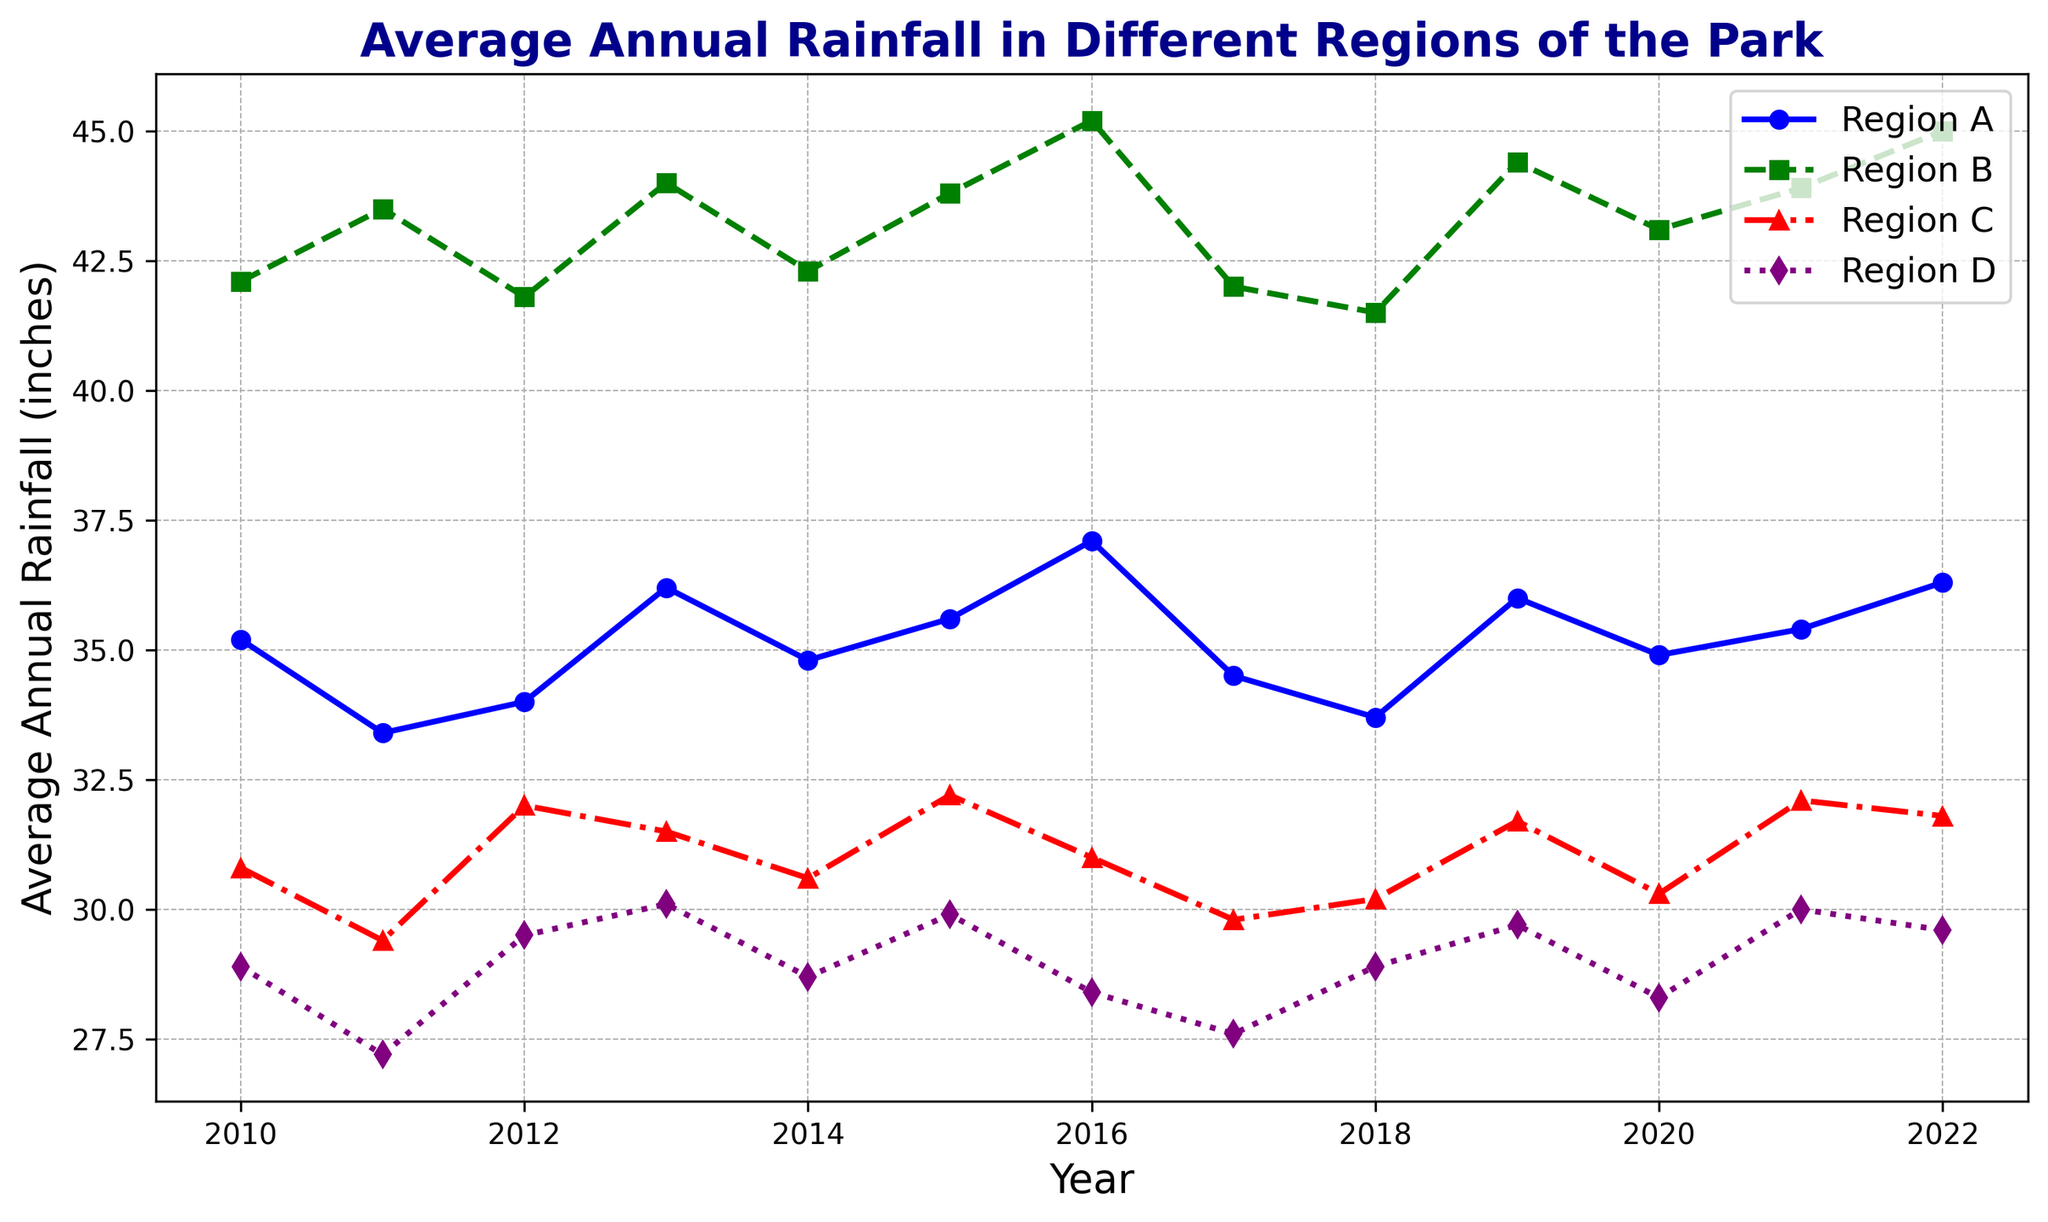What's the trend of the average annual rainfall in Region A from 2010 to 2022? To determine the trend in Region A, observe the plotted line representing Region A (blue line). The line generally rises over the years, suggesting an increasing trend in average annual rainfall.
Answer: Increasing trend Which year had the highest average annual rainfall in Region B, and what was the value? Identify the highest point on the green dashed line that represents Region B and check the corresponding year. In 2016, Region B had the highest rainfall at 45.2 inches.
Answer: 2016, 45.2 inches Between 2015 and 2019, did Region C see an increase or decrease in average annual rainfall? Look at the red dashed-dotted line for Region C and compare its values from 2015 to 2019. In 2015, the value is 32.2 inches, and in 2019, it is 31.7 inches, indicating a slight decrease.
Answer: Decrease Which region had the most fluctuating annual rainfall from 2010 to 2022? By observing all lines on the chart, Region B (green dashed line) shows the most significant variations in its values, indicating the highest fluctuation.
Answer: Region B On average, which region had the least average annual rainfall over the selected years? To find the average, calculate the mean rainfall for each region over the years. Summing the values and dividing by the number of years for Region D (purple dotted line) gives the smallest average value compared to other regions.
Answer: Region D In 2020, how did the average annual rainfall of Region D compare to Region A? Compare the value of Region D (purple dotted line) and Region A (blue line) in 2020. Region D's rainfall is 28.3 inches while Region A's rainfall is 34.9 inches.
Answer: Region A had higher rainfall What's the average rainfall in Region C in years when it was lower than 31 inches? Find the years where Region C (red dashed-dotted line) had values lower than 31 inches, which occurs in 2010, 2011, 2017, and 2020. The rainfall values for these years are 30.8, 29.4, 29.8, and 30.3 inches. Compute their average: (30.8 + 29.4 + 29.8 + 30.3) / 4 = 30.08 inches.
Answer: 30.08 inches Which year saw the smallest difference in average annual rainfall between Region A and Region D? To find the smallest difference, subtract the annual rainfall of Region D from Region A for each year and compare the results. The smallest difference is in 2010, with Region A at 35.2 inches and Region D at 28.9 inches. The difference is 35.2 - 28.9 = 6.3 inches.
Answer: 2010 Is there a year where the average annual rainfall for all regions was less than 35 inches? Check each year, comparing all regions' values against the threshold of 35 inches. In 2017, all regions (Region A: 34.5, Region B: 42, Region C: 29.8, Region D: 27.6) don't satisfy this condition as Region B and Region A exceed 35 inches in nearly all cases.
Answer: No Which region shows a decreasing trend from 2020 to 2022? Inspect the trends of all regions from 2020 to 2022. Region D (purple dotted line) experiences a slight decrease in average annual rainfall from 28.3 inches in 2020 to 29.6 inches in 2022.
Answer: Region D 